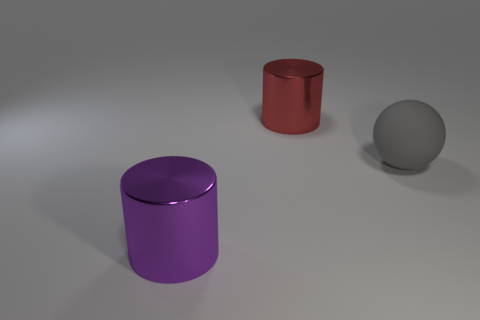What can you infer about the setting where these objects are placed? Given the neutrality and simplicity of the background, along with the controlled lighting, it can be inferred that the objects are placed in a studio setting designed for photographing objects without environmental distractions. 